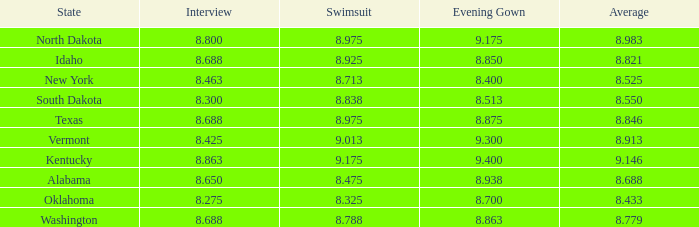Who had the lowest interview score from South Dakota with an evening gown less than 8.513? None. 